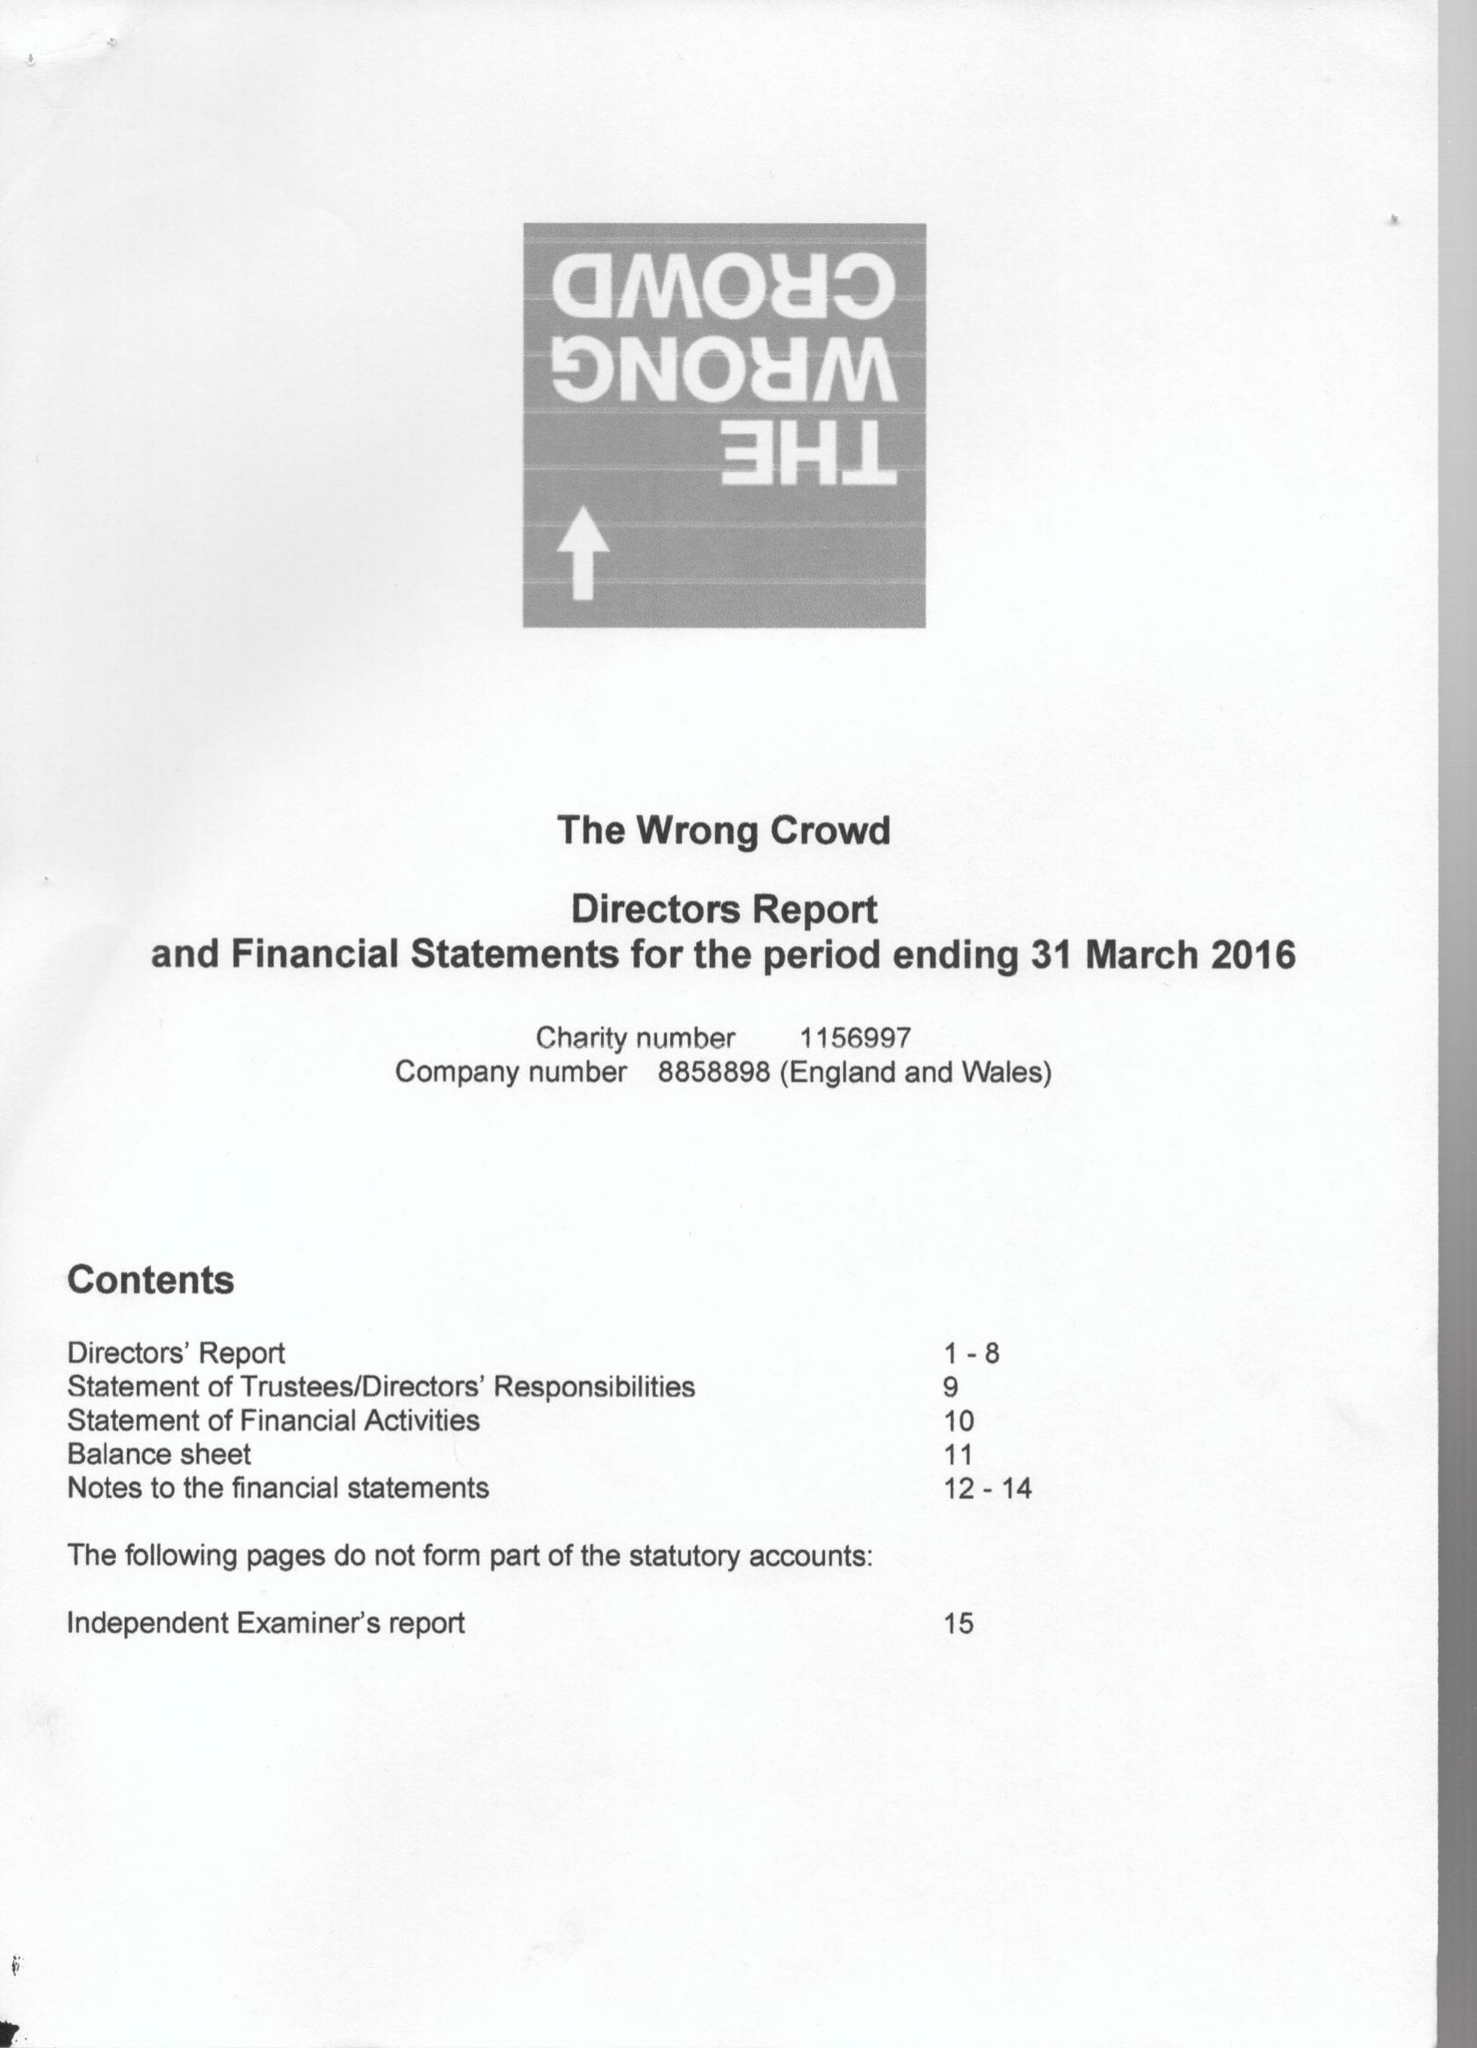What is the value for the charity_name?
Answer the question using a single word or phrase. The Wrong Crowd 